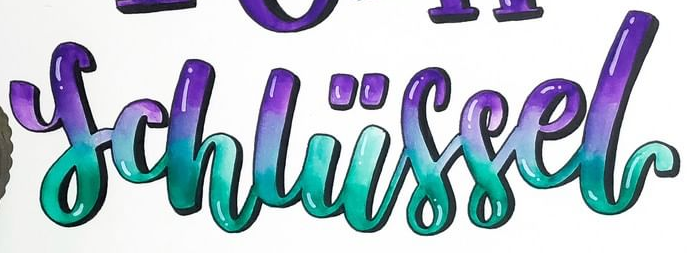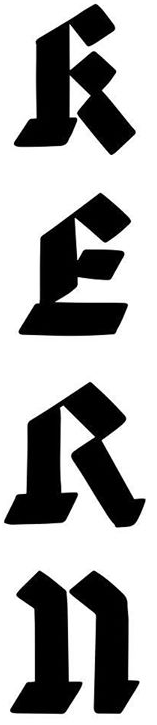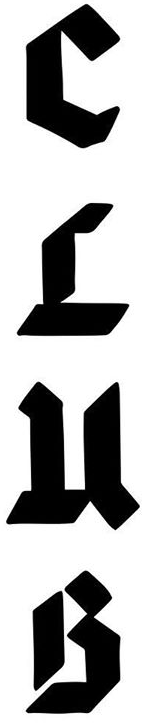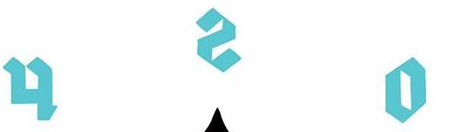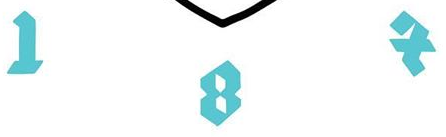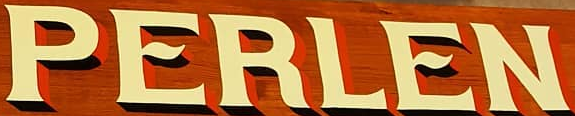Transcribe the words shown in these images in order, separated by a semicolon. schliissel; RERn; CLuB; osh; IBX; PERLEN 